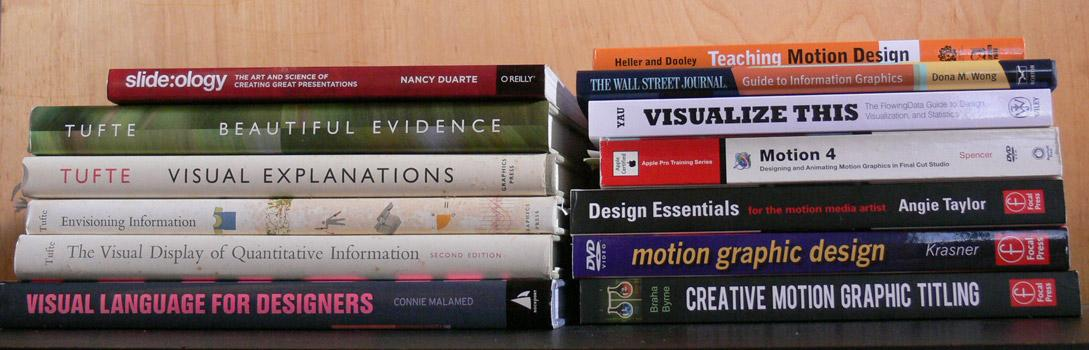Specify some key components in this picture. Braha Byrne is the author of creative motion graphic titling. Four books by Tufte are displayed. There are 13 books that are currently being shown. The book shown by YAU is named VISUALIZE THIS. 